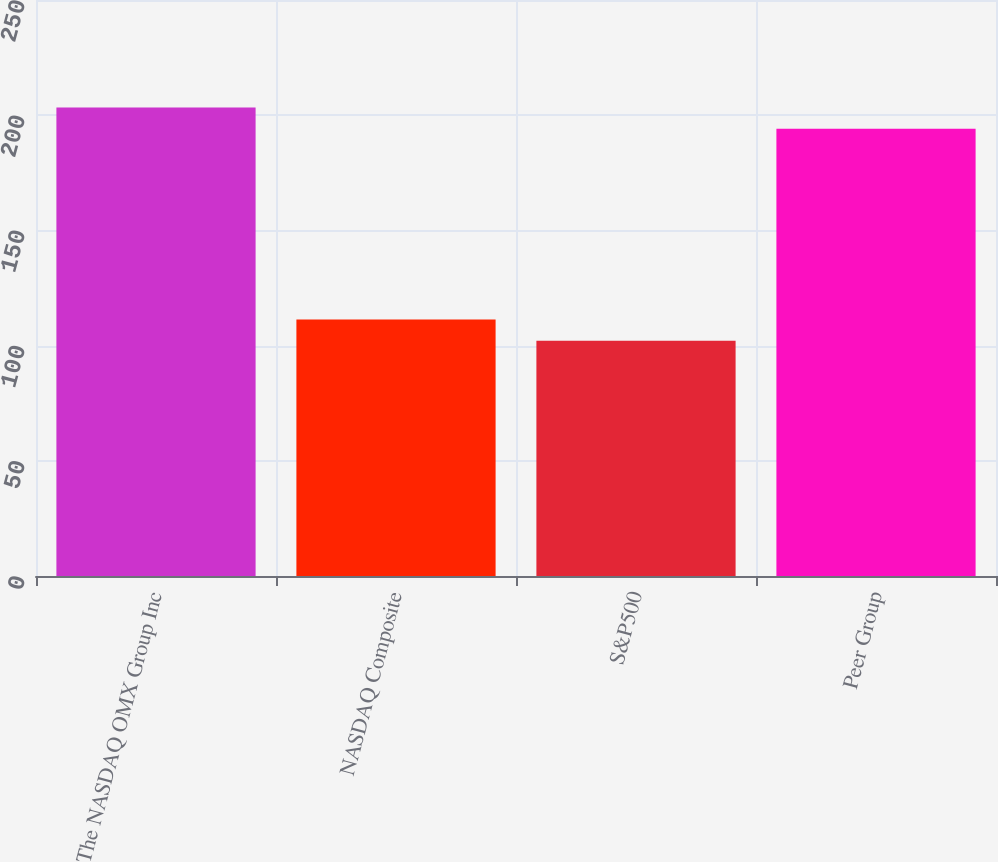Convert chart to OTSL. <chart><loc_0><loc_0><loc_500><loc_500><bar_chart><fcel>The NASDAQ OMX Group Inc<fcel>NASDAQ Composite<fcel>S&P500<fcel>Peer Group<nl><fcel>203.39<fcel>111.33<fcel>102.11<fcel>194.17<nl></chart> 